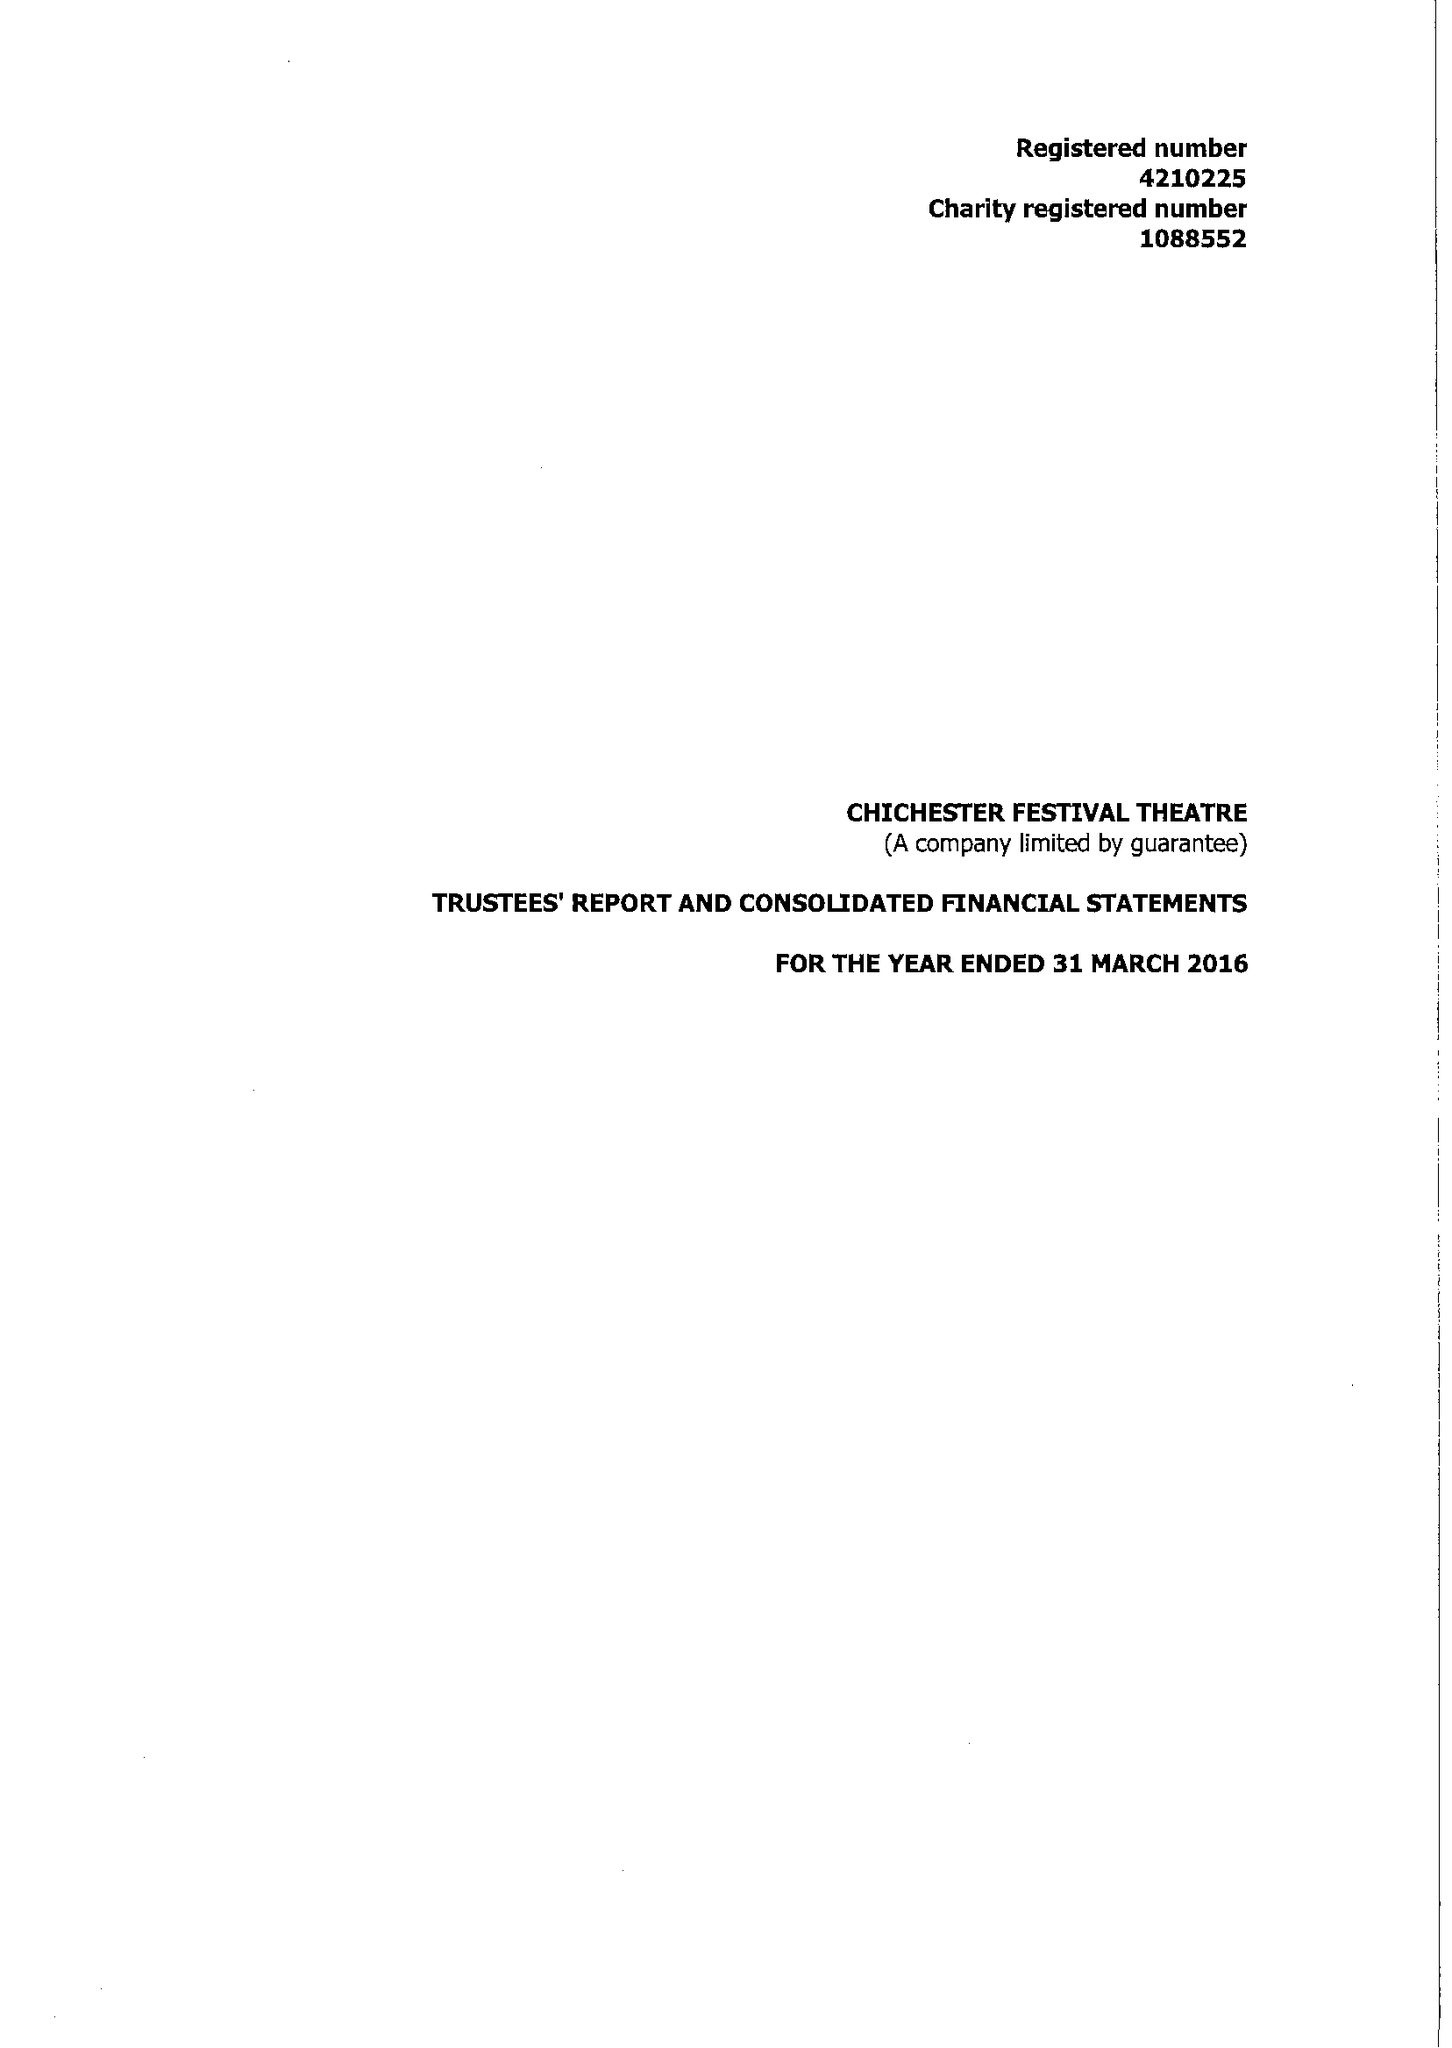What is the value for the income_annually_in_british_pounds?
Answer the question using a single word or phrase. 14668463.00 